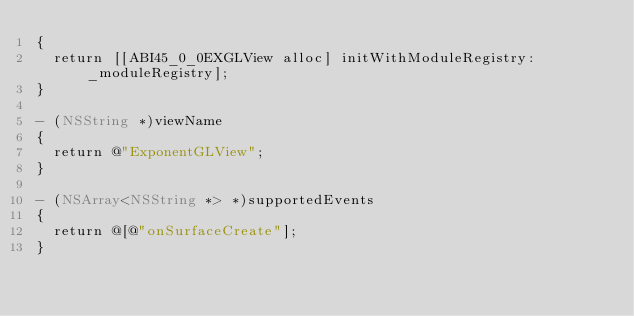<code> <loc_0><loc_0><loc_500><loc_500><_ObjectiveC_>{
  return [[ABI45_0_0EXGLView alloc] initWithModuleRegistry:_moduleRegistry];
}

- (NSString *)viewName
{
  return @"ExponentGLView";
}

- (NSArray<NSString *> *)supportedEvents
{
  return @[@"onSurfaceCreate"];
}
</code> 